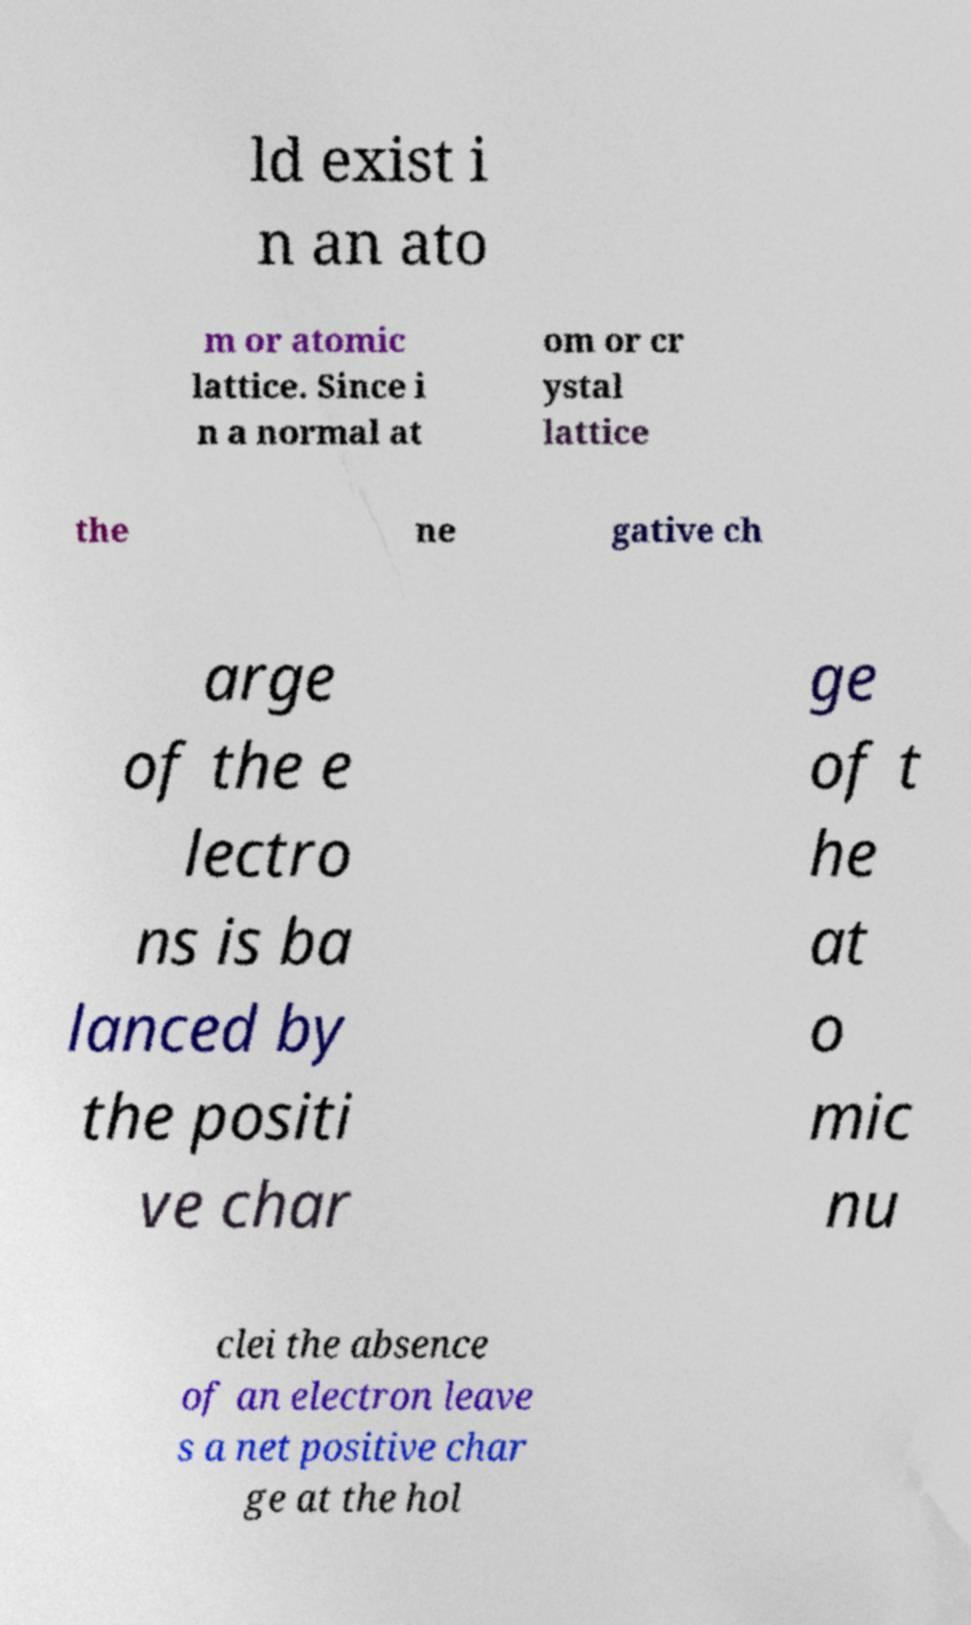Please read and relay the text visible in this image. What does it say? ld exist i n an ato m or atomic lattice. Since i n a normal at om or cr ystal lattice the ne gative ch arge of the e lectro ns is ba lanced by the positi ve char ge of t he at o mic nu clei the absence of an electron leave s a net positive char ge at the hol 